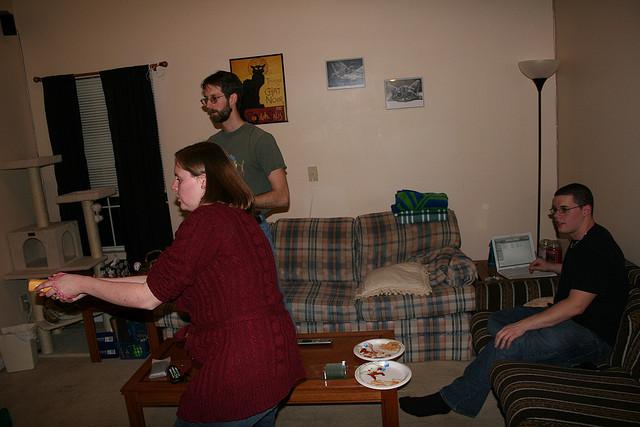Do the windows have curtains?
Give a very brief answer. Yes. Is she flipping television channels?
Be succinct. No. What colors are the pillows?
Concise answer only. Tan. What room is this?
Short answer required. Living room. What is she doing?
Give a very brief answer. Playing wii. Is this woman having a party?
Keep it brief. No. Does he have a beard?
Short answer required. Yes. Is that at nighttime?
Give a very brief answer. Yes. Are there any adults in this photo?
Concise answer only. Yes. Have they ordered food yet?
Keep it brief. Yes. What is the pattern on the curtain?
Short answer required. Solid. Which way is the woman looking?
Give a very brief answer. Straight. What type of cake is that?
Give a very brief answer. Birthday. Are the kids being active?
Write a very short answer. No. What color are this lady's pants?
Quick response, please. Blue. What season is it?
Write a very short answer. Fall. Is that a Wii controller?
Write a very short answer. Yes. Is it day or night?
Quick response, please. Night. Is there a girl playing the game?
Quick response, please. Yes. What color are the couches?
Concise answer only. Plaid. Who is the oldest of the three men?
Be succinct. One sitting down. What kind of shirt is the man wearing?
Give a very brief answer. T-shirt. What is the woman holding in her right hand?
Concise answer only. Wiimote. Where was this picture taken?
Concise answer only. Living room. How many people are in the picture on the mantle?
Answer briefly. 0. What game system is she playing?
Concise answer only. Wii. What color is her sweater?
Keep it brief. Red. What is the piece of furniture to right of couch called?
Write a very short answer. Love seat. Who has green socks on?
Be succinct. Man. What team Jersey is the boy wearing?
Be succinct. None. What color is the picture frame?
Short answer required. Black. What is in the right corner of the photo?
Concise answer only. Lamp. What is hanging on the wall?
Keep it brief. Pictures. Is the plate ready to be washed?
Write a very short answer. Yes. What color is the sofa?
Concise answer only. Plaid. Are all the men wearing long sleeves?
Give a very brief answer. No. Does he sleep on that couch?
Write a very short answer. No. What animal can be seen on a poster behind the man that is standing in this picture?
Answer briefly. Cat. Is her hair in a ponytail?
Short answer required. No. What kind of food is the man holding?
Concise answer only. Pizza. What is the man sitting in?
Answer briefly. Couch. What pattern is on her shirt?
Be succinct. Cable knit. Is there a stairway behind them?
Write a very short answer. No. What room is the lady in?
Be succinct. Living room. Is the lamp off?
Short answer required. Yes. How many picture frames are seen on the wall?
Be succinct. 3. Where is this location?
Keep it brief. Living room. What is the woman pointing too?
Short answer required. Tv. Is there anyone in the room?
Concise answer only. Yes. How many visible tattoos are there?
Answer briefly. 0. Who is going to get the food on the plate?
Keep it brief. Man. How many people are wearing glasses?
Short answer required. 2. What two things  are on the table?
Short answer required. Plates. What is the table made of?
Keep it brief. Wood. Is this a man or woman?
Be succinct. Woman. Is the female wearing glasses?
Answer briefly. No. Is that a man?
Quick response, please. Yes. Can I pay to listen to music here?
Keep it brief. No. Are these men on a vertical or horizontal surface?
Quick response, please. Horizontal. What color shirt is the closest lady to the camera?
Write a very short answer. Red. Is the man with the brown hair wearing a tight shirt or a loose shirt?
Concise answer only. Loose. What is the color of the man's beard?
Concise answer only. Brown. What are the words on the green shirt?
Keep it brief. No words. Ignoring the tenants of rule #34, is this image pornographic?
Concise answer only. No. Is the boy on the right wearing a scarf?
Give a very brief answer. No. What color is the couch cover?
Quick response, please. Plaid. Is a lamp on?
Be succinct. No. Where is the light switch?
Concise answer only. Wall. Is it daytime?
Answer briefly. No. What color is the bowl?
Concise answer only. White. Which players has the most pictures behind them?
Be succinct. Man. How many laptops are visible?
Answer briefly. 1. How many people?
Short answer required. 3. What color is the wall to the right of the people?
Give a very brief answer. Beige. What is against the wall?
Keep it brief. Couch. Could these people be related?
Short answer required. Yes. Does the window have any covering?
Keep it brief. Yes. How many people are standing?
Be succinct. 2. What is the dark colored stripe on the woman's top?
Concise answer only. Belt. What color is the controller?
Give a very brief answer. Yellow. What is she holding?
Short answer required. Remote. Is anyone sitting on the couch?
Keep it brief. Yes. What colors are in the carpet?
Keep it brief. Tan. What shape is present in the painting on the wall?
Quick response, please. Cat. What is on the couch near the woman?
Keep it brief. Pillow. Was this picture recently taken?
Be succinct. Yes. Is there a lamp in the picture?
Answer briefly. Yes. What is hanging from the ceiling?
Short answer required. Nothing. Is he being lazy on the couch?
Concise answer only. No. What is the most likely relationship of these people?
Give a very brief answer. Friends. Are there reflections on  the table?
Give a very brief answer. No. Are they celebrating a birthday?
Give a very brief answer. No. What color laptop is in this picture?
Concise answer only. White. What season is this?
Concise answer only. Winter. How many people are seated?
Short answer required. 1. Where is the computer?
Quick response, please. Table. 